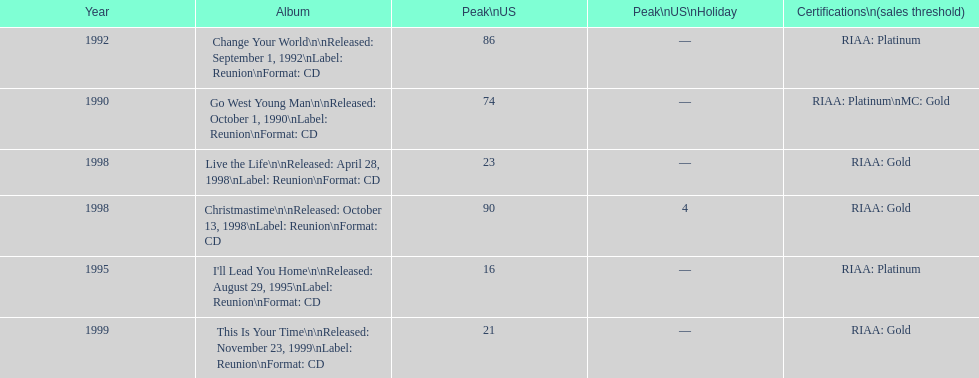Could you parse the entire table as a dict? {'header': ['Year', 'Album', 'Peak\\nUS', 'Peak\\nUS\\nHoliday', 'Certifications\\n(sales threshold)'], 'rows': [['1992', 'Change Your World\\n\\nReleased: September 1, 1992\\nLabel: Reunion\\nFormat: CD', '86', '—', 'RIAA: Platinum'], ['1990', 'Go West Young Man\\n\\nReleased: October 1, 1990\\nLabel: Reunion\\nFormat: CD', '74', '—', 'RIAA: Platinum\\nMC: Gold'], ['1998', 'Live the Life\\n\\nReleased: April 28, 1998\\nLabel: Reunion\\nFormat: CD', '23', '—', 'RIAA: Gold'], ['1998', 'Christmastime\\n\\nReleased: October 13, 1998\\nLabel: Reunion\\nFormat: CD', '90', '4', 'RIAA: Gold'], ['1995', "I'll Lead You Home\\n\\nReleased: August 29, 1995\\nLabel: Reunion\\nFormat: CD", '16', '—', 'RIAA: Platinum'], ['1999', 'This Is Your Time\\n\\nReleased: November 23, 1999\\nLabel: Reunion\\nFormat: CD', '21', '—', 'RIAA: Gold']]} What year comes after 1995? 1998. 